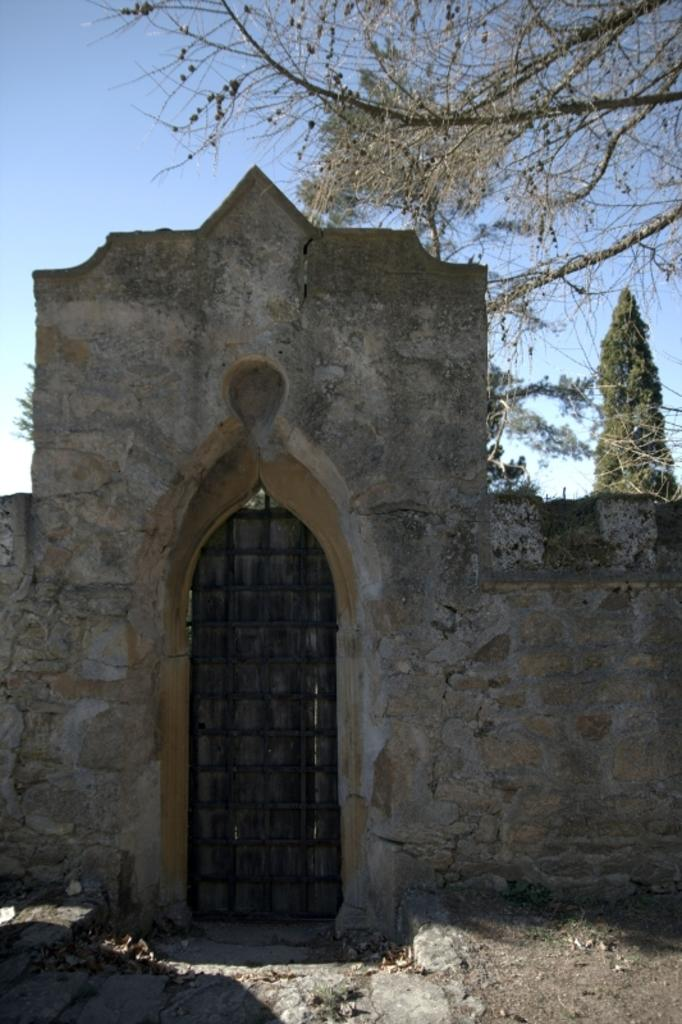What is a prominent feature in the image? There is a wall in the image. Is there any opening in the wall? Yes, there is a door in the wall. What can be seen in the background of the image? There are trees and the sky visible in the background of the image. How many tickets are visible in the image? There are no tickets present in the image. Can you describe the family members in the image? There is no family present in the image; it only features a wall, a door, trees, and the sky. 